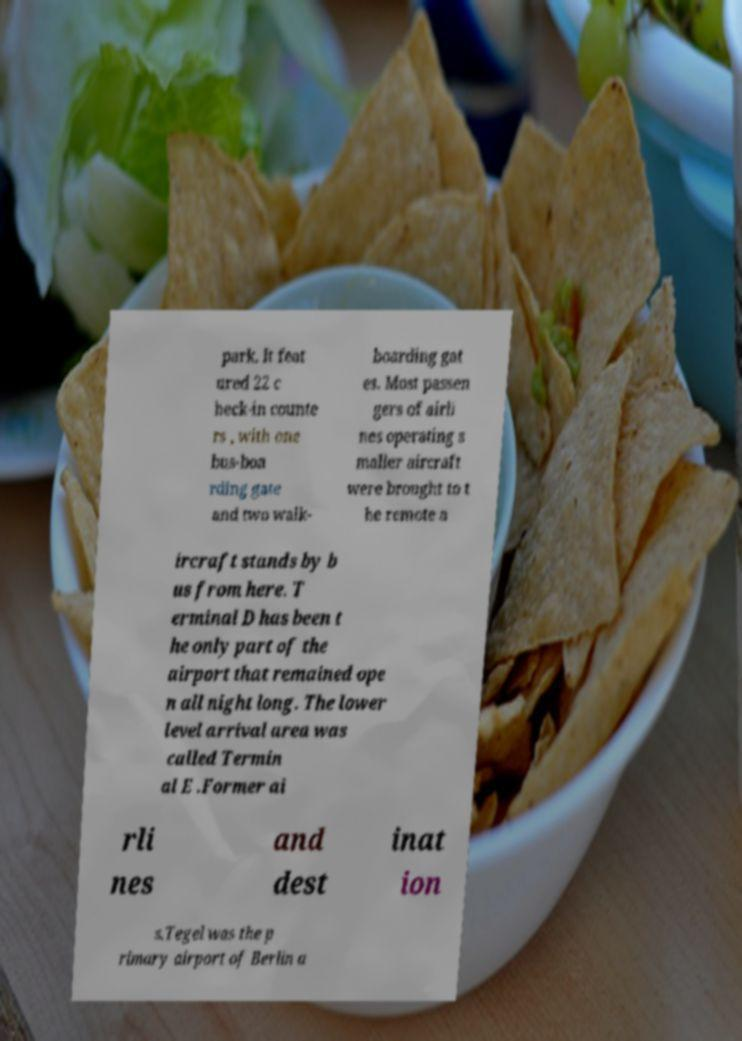I need the written content from this picture converted into text. Can you do that? park. It feat ured 22 c heck-in counte rs , with one bus-boa rding gate and two walk- boarding gat es. Most passen gers of airli nes operating s maller aircraft were brought to t he remote a ircraft stands by b us from here. T erminal D has been t he only part of the airport that remained ope n all night long. The lower level arrival area was called Termin al E .Former ai rli nes and dest inat ion s.Tegel was the p rimary airport of Berlin a 